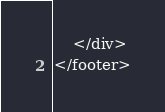Convert code to text. <code><loc_0><loc_0><loc_500><loc_500><_PHP_>    </div>
</footer></code> 